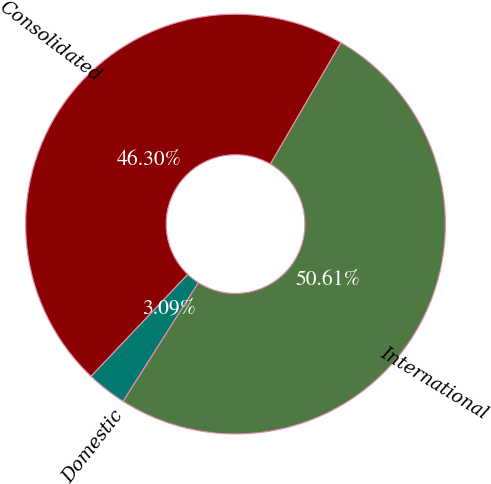Convert chart to OTSL. <chart><loc_0><loc_0><loc_500><loc_500><pie_chart><fcel>Consolidated<fcel>Domestic<fcel>International<nl><fcel>46.3%<fcel>3.09%<fcel>50.61%<nl></chart> 